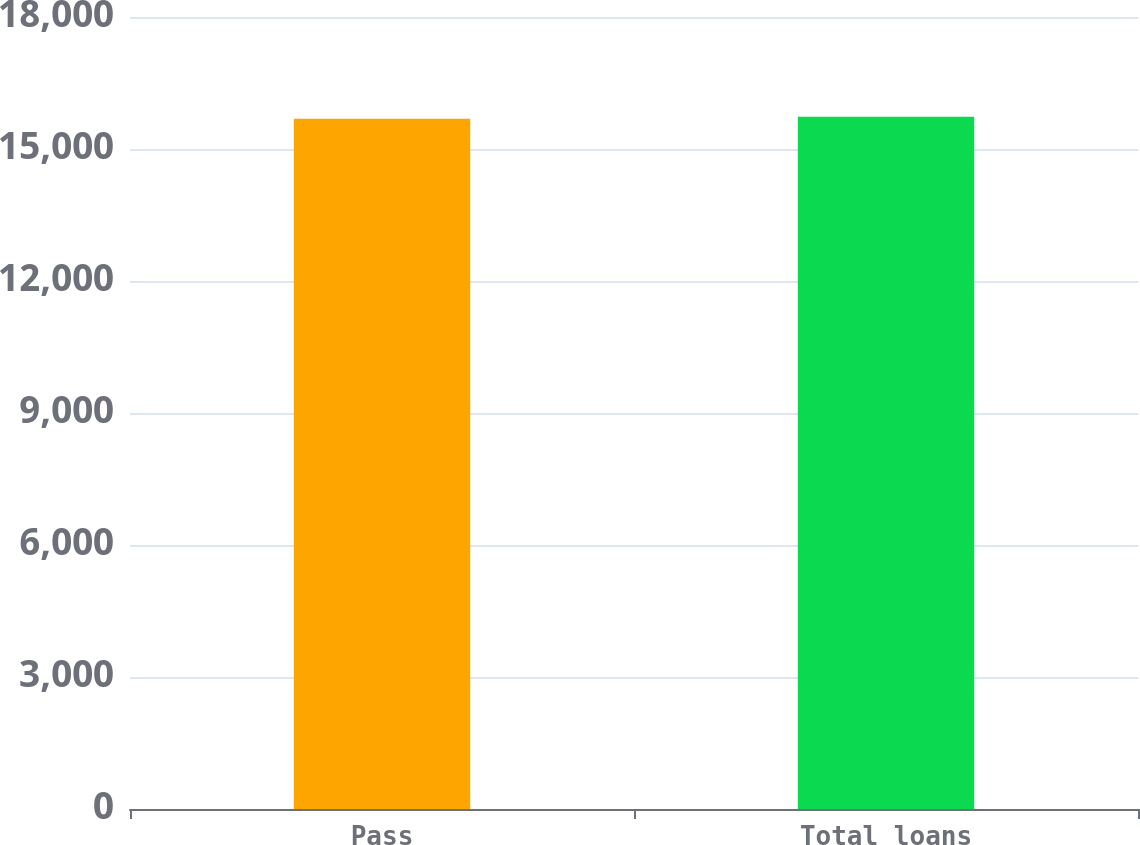<chart> <loc_0><loc_0><loc_500><loc_500><bar_chart><fcel>Pass<fcel>Total loans<nl><fcel>15688<fcel>15735<nl></chart> 